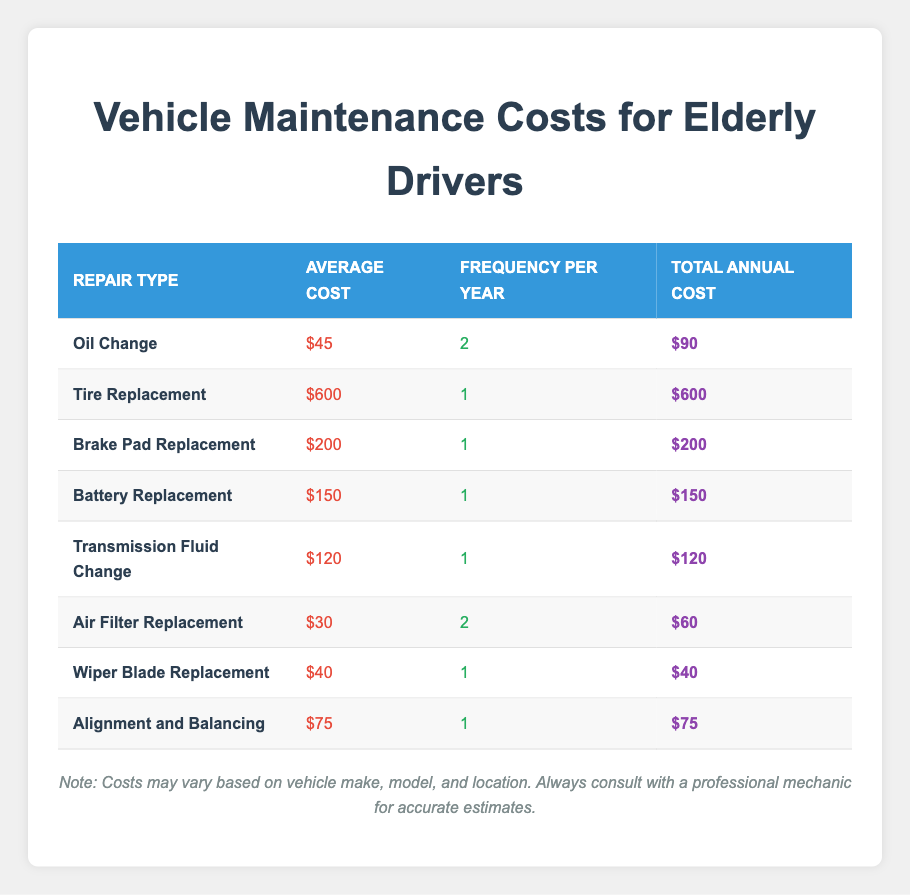What is the total annual cost for an oil change? The table shows that the total annual cost for an oil change is listed in the "Total Annual Cost" column for the "Oil Change" row, which is $90.
Answer: $90 What is the average cost of a battery replacement? The average cost of a battery replacement can be found in the corresponding row in the "Average Cost" column, which is $150.
Answer: $150 How many repairs have an annual cost greater than $100? To determine this, we can look at the "Total Annual Cost" column and count the rows where the cost is higher than $100: Tire Replacement ($600), Brake Pad Replacement ($200), Battery Replacement ($150), and Transmission Fluid Change ($120). This totals to 4 repairs.
Answer: 4 What is the average total annual cost for all repairs? First, we sum the total annual costs for all repairs: 90 + 600 + 200 + 150 + 120 + 60 + 40 + 75 = 1,335. Then, divide by the number of repairs, which is 8. Therefore, 1,335 divided by 8 equals 166.875. Rounding this gives an average total annual cost of approximately $166.88.
Answer: $166.88 Is the frequency of air filter replacement higher than that of battery replacement? The frequency of air filter replacement is 2 per year, while the frequency of battery replacement is 1 per year. Since 2 is greater than 1, the answer is yes.
Answer: Yes Which repair type has the highest average cost? Looking at the "Average Cost" column, we can see that Tire Replacement has the highest cost at $600, compared to all other repair types.
Answer: Tire Replacement What is the total annual cost of replacing the air filter and wiper blades combined? For air filter replacement, the total annual cost is $60 and for wiper blade replacement, it is $40. Adding these together gives 60 + 40 = 100.
Answer: $100 Are there any repairs that occur more than once a year? Checking the "Frequency Per Year" column, we see that Oil Change and Air Filter Replacement both occur 2 times a year. Therefore, the answer is yes, there are repairs that occur more than once a year.
Answer: Yes What is the difference in total annual cost between the most expensive and the least expensive repair? The most expensive repair is Tire Replacement at $600 and the least expensive is Wiper Blade Replacement at $40. The difference is calculated as 600 - 40 = 560.
Answer: $560 